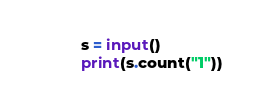Convert code to text. <code><loc_0><loc_0><loc_500><loc_500><_Python_>s = input()
print(s.count("1"))</code> 